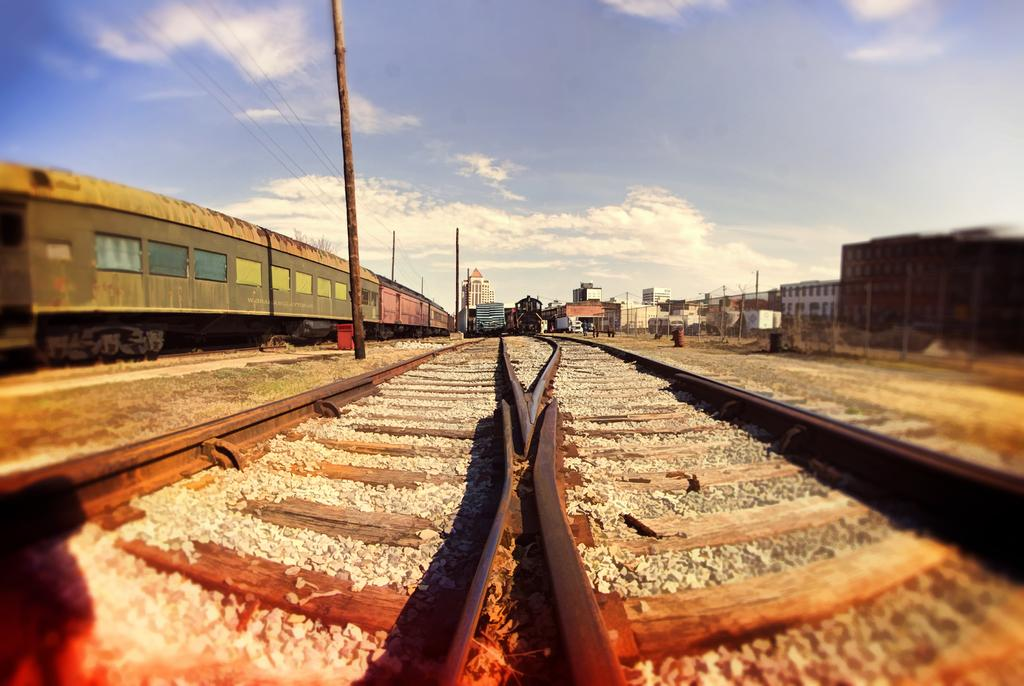What can be seen running along the ground in the image? There are train tracks in the image. What is moving along the train tracks? There are trains on the tracks. What type of structures can be seen in the distance in the image? There are houses in the background of the image. What is visible above the houses and train tracks in the image? The sky is visible in the background of the image. What type of sweater is the train wearing in the image? Trains do not wear sweaters; they are inanimate objects. 